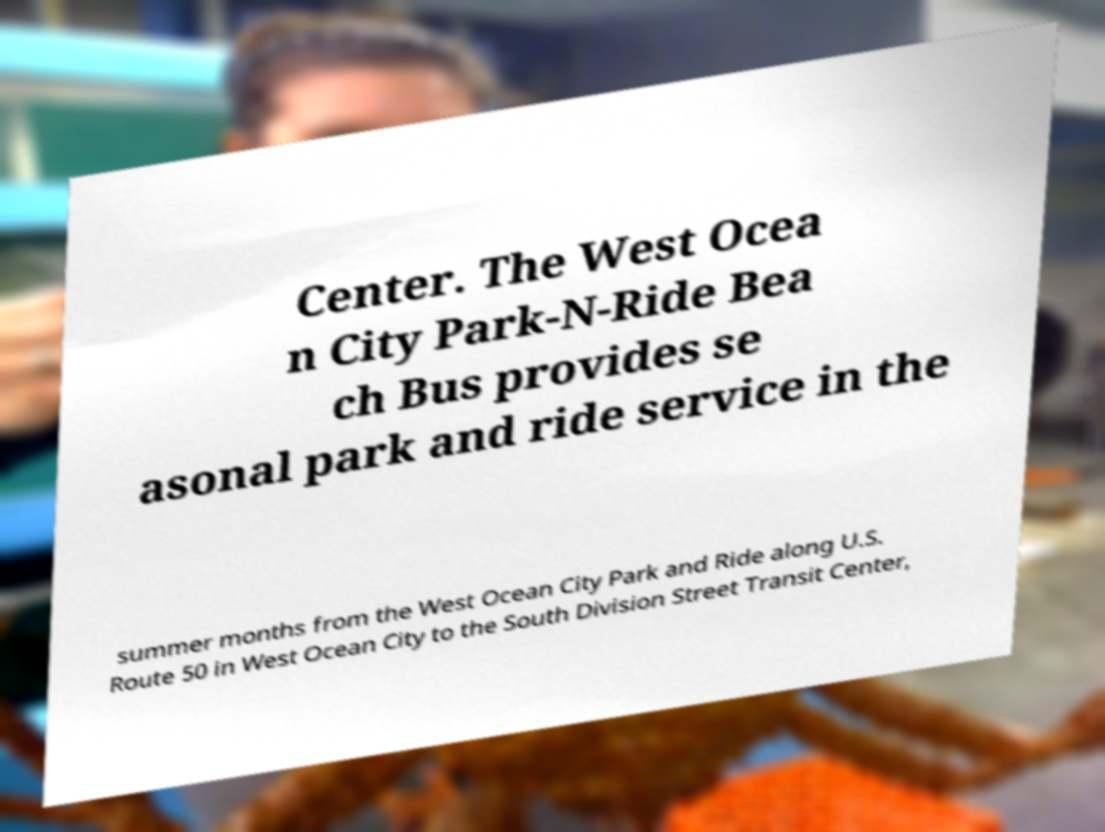Please identify and transcribe the text found in this image. Center. The West Ocea n City Park-N-Ride Bea ch Bus provides se asonal park and ride service in the summer months from the West Ocean City Park and Ride along U.S. Route 50 in West Ocean City to the South Division Street Transit Center, 